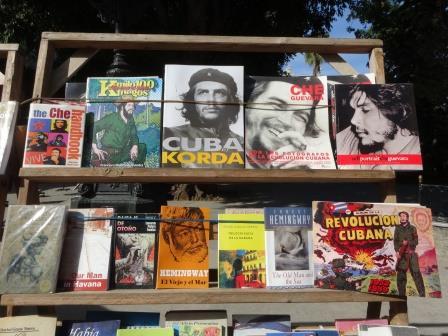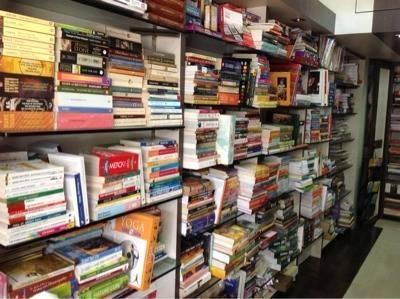The first image is the image on the left, the second image is the image on the right. Given the left and right images, does the statement "Black wires can be seen in one of the images." hold true? Answer yes or no. Yes. The first image is the image on the left, the second image is the image on the right. Analyze the images presented: Is the assertion "One of the images is of writing supplies, hanging on a wall." valid? Answer yes or no. No. 